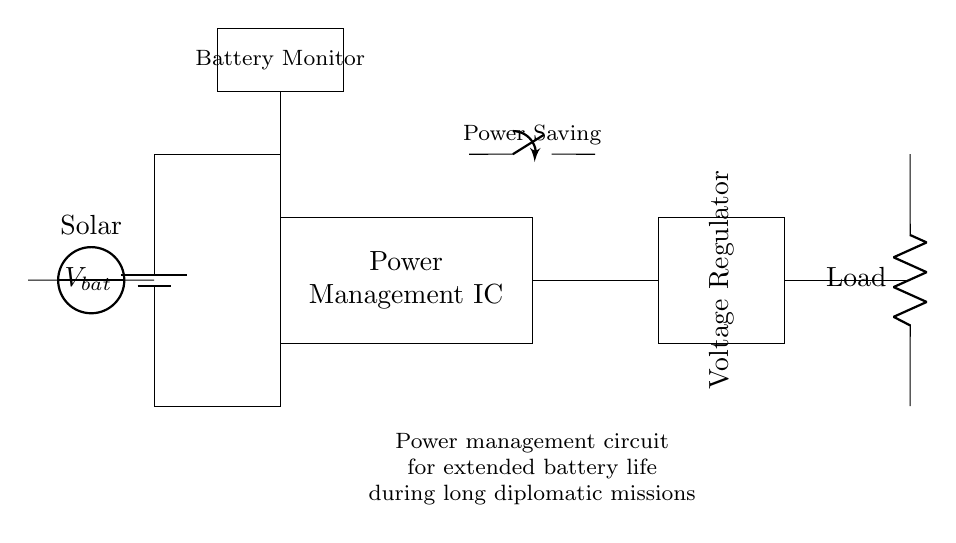What is the main purpose of this circuit? The circuit is designed to manage power efficiently, particularly to extend battery life during long diplomatic missions. This is evident from the labeled components and the note at the bottom explaining its purpose.
Answer: power management What component is responsible for voltage regulation? The component responsible for voltage regulation is the Voltage Regulator, as shown in the diagram where it is labeled and situated at the middle right section.
Answer: Voltage Regulator What is the voltage source used for solar charging? The voltage source used for solar charging is indicated in the diagram as a Solar source, which is positioned at the left side of the circuit connecting to the battery.
Answer: Solar How does the Power Saving Switch contribute to battery life? The Power Saving Switch allows the user to turn off unnecessary parts of the circuit when not in use, reducing power consumption. This inference comes from its labeled purpose and placement above the battery connections.
Answer: reduces power consumption How many main components are present in this circuit? The circuit contains five main components: Battery, Power Management IC, Voltage Regulator, Load, and Battery Monitor. Counting these labeled parts gives a clear total.
Answer: five What is the function of the Battery Monitor in this circuit? The Battery Monitor tracks the voltage and status of the battery, ensuring that the power management system operates efficiently based on the current battery state. This is derived from the function associated with the monitor in managing power.
Answer: monitors battery status What kind of load is specified in the circuit? The load specified in the circuit is labeled simply as Load, which indicates that any electrical device can be connected at this point. The term Load typically refers to a device that consumes power.
Answer: Load 